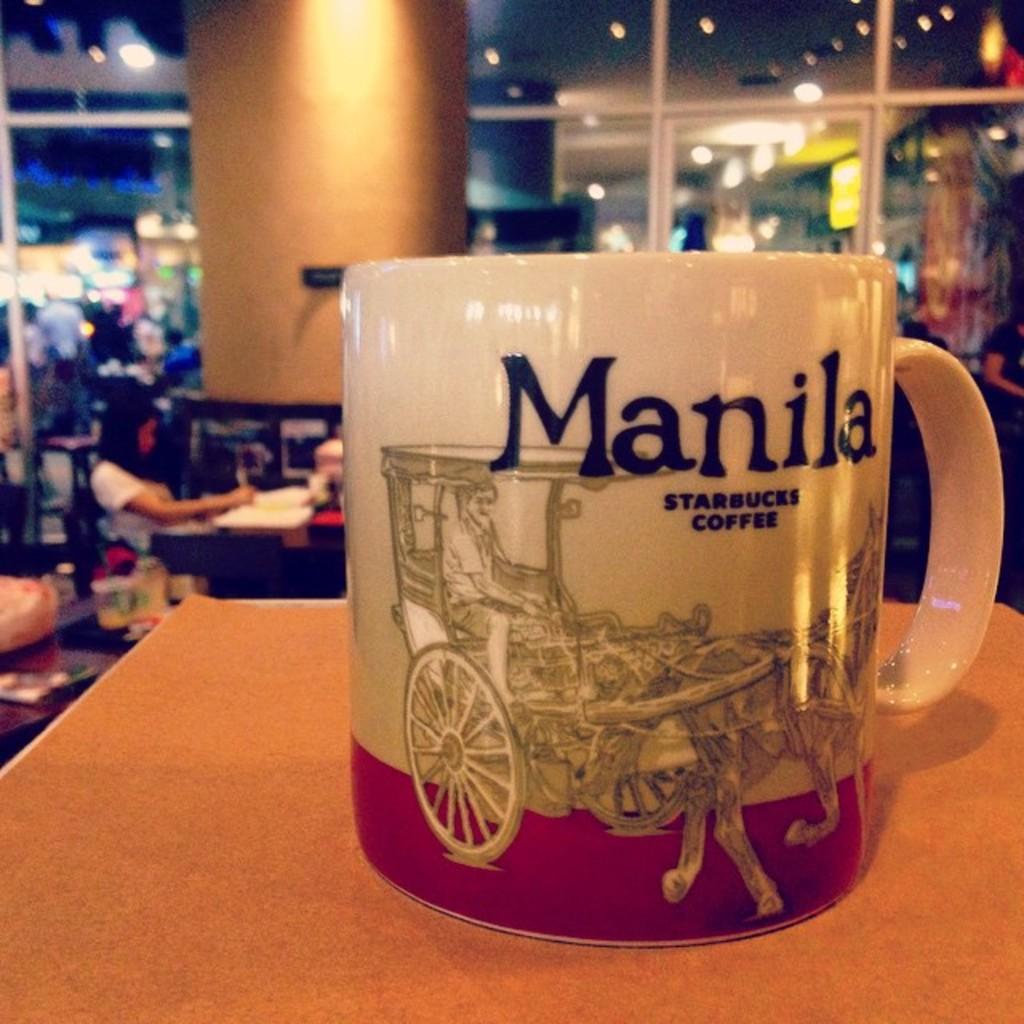Could you give a brief overview of what you see in this image? It is a cup, there is an art on this of a man is riding the horse cart. 